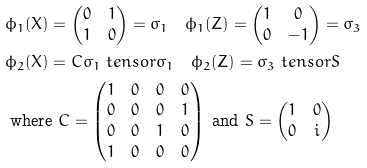Convert formula to latex. <formula><loc_0><loc_0><loc_500><loc_500>& \phi _ { 1 } ( X ) = \begin{pmatrix} 0 & 1 \\ 1 & 0 \end{pmatrix} = \sigma _ { 1 } \quad \phi _ { 1 } ( Z ) = \begin{pmatrix} 1 & 0 \\ 0 & - 1 \end{pmatrix} = \sigma _ { 3 } \\ & \phi _ { 2 } ( X ) = C \sigma _ { 1 } \ t e n s o r \sigma _ { 1 } \quad \phi _ { 2 } ( Z ) = \sigma _ { 3 } \ t e n s o r S \\ & \text { where } C = \begin{pmatrix} 1 & 0 & 0 & 0 \\ 0 & 0 & 0 & 1 \\ 0 & 0 & 1 & 0 \\ 1 & 0 & 0 & 0 \end{pmatrix} \text { and } S = \begin{pmatrix} 1 & 0 \\ 0 & i \end{pmatrix} \\</formula> 